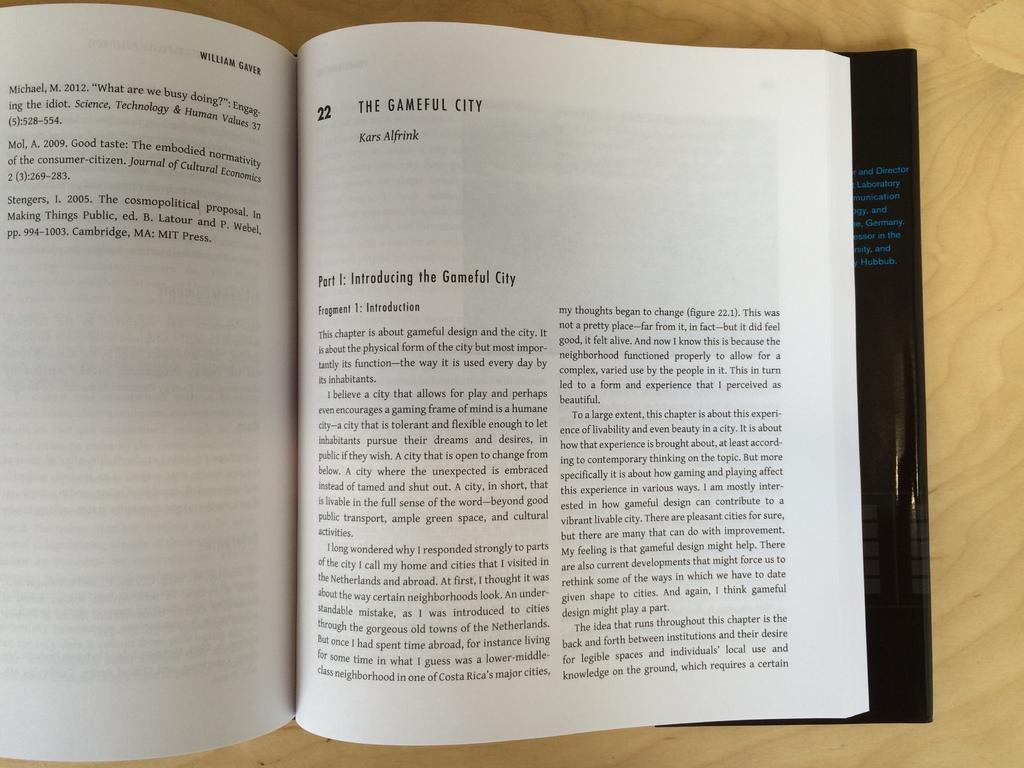What kind of city is it?
Ensure brevity in your answer.  Gameful. Who wrote this book and/or chapter?
Your answer should be compact. Kars alfrink. 